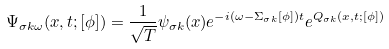<formula> <loc_0><loc_0><loc_500><loc_500>\Psi _ { \sigma k \omega } ( x , t ; [ \phi ] ) = \frac { 1 } { \sqrt { T } } \psi _ { \sigma k } ( x ) e ^ { - i ( \omega - \Sigma _ { \sigma k } [ \phi ] ) t } e ^ { Q _ { \sigma k } ( x , t ; [ \phi ] ) }</formula> 